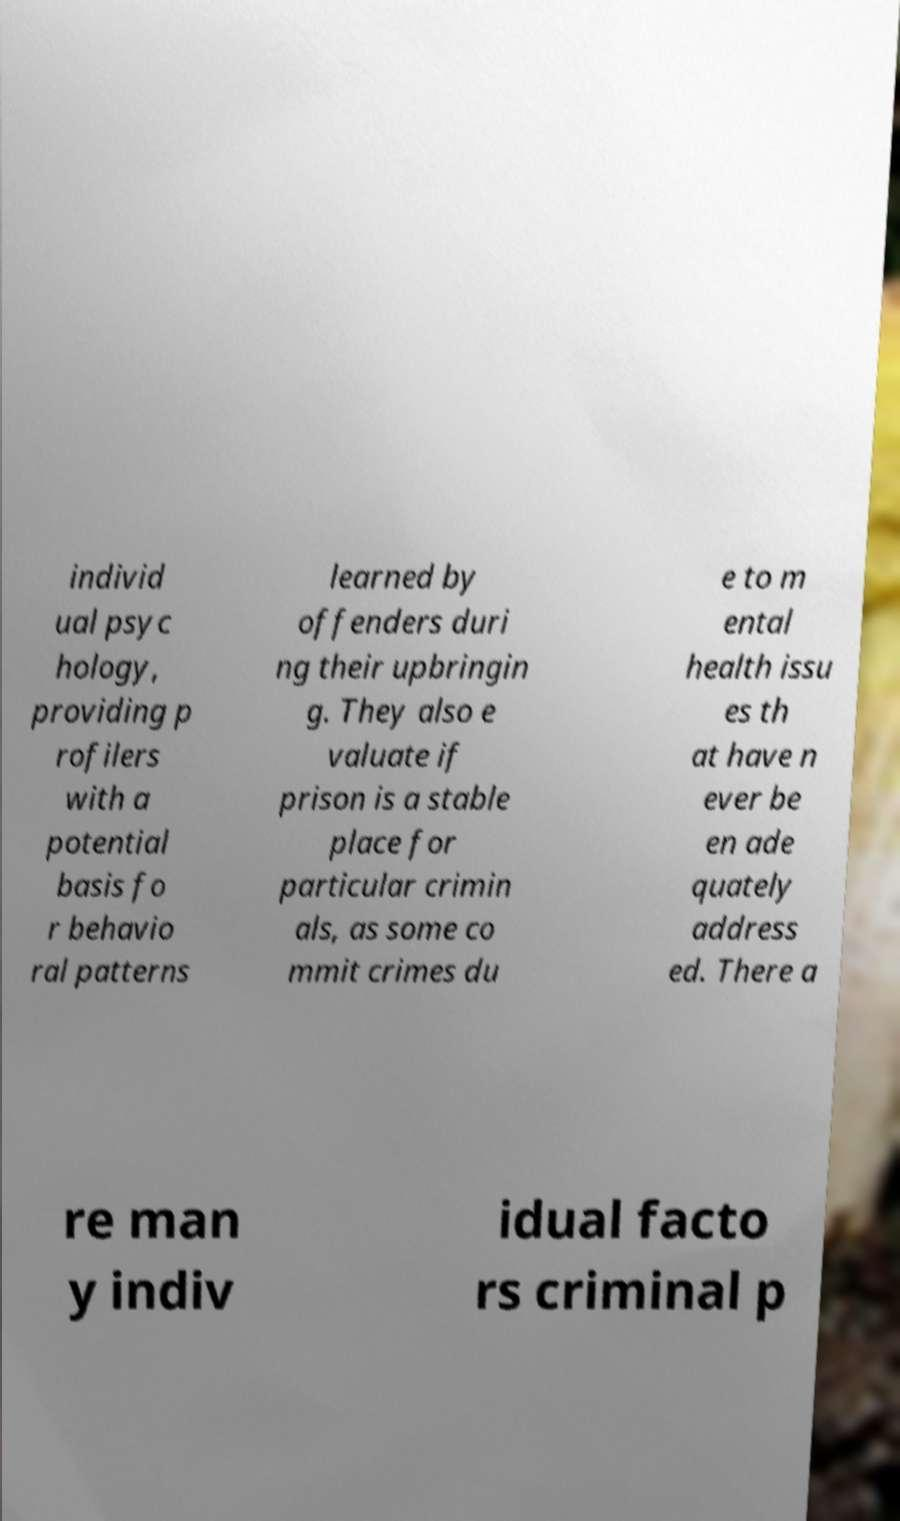Can you read and provide the text displayed in the image?This photo seems to have some interesting text. Can you extract and type it out for me? individ ual psyc hology, providing p rofilers with a potential basis fo r behavio ral patterns learned by offenders duri ng their upbringin g. They also e valuate if prison is a stable place for particular crimin als, as some co mmit crimes du e to m ental health issu es th at have n ever be en ade quately address ed. There a re man y indiv idual facto rs criminal p 